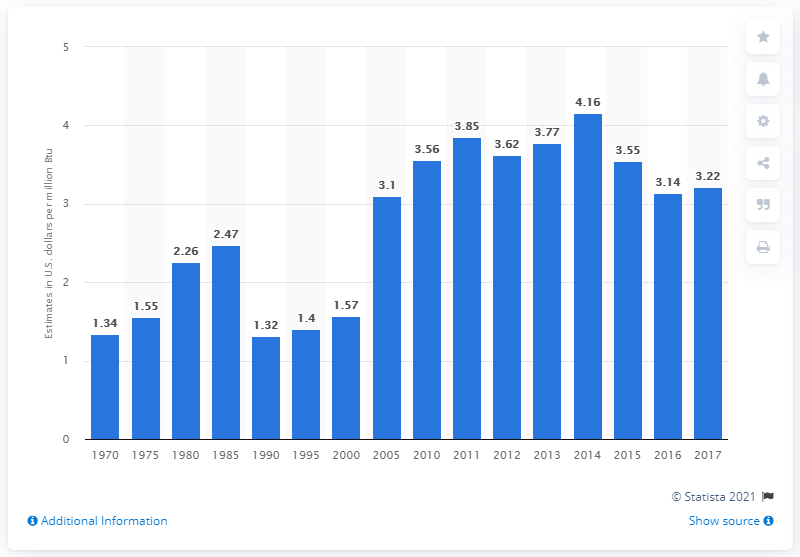Highlight a few significant elements in this photo. In 2017, the estimated cost of biomass for energy production was approximately 3.22 dollars per million British thermal units. 